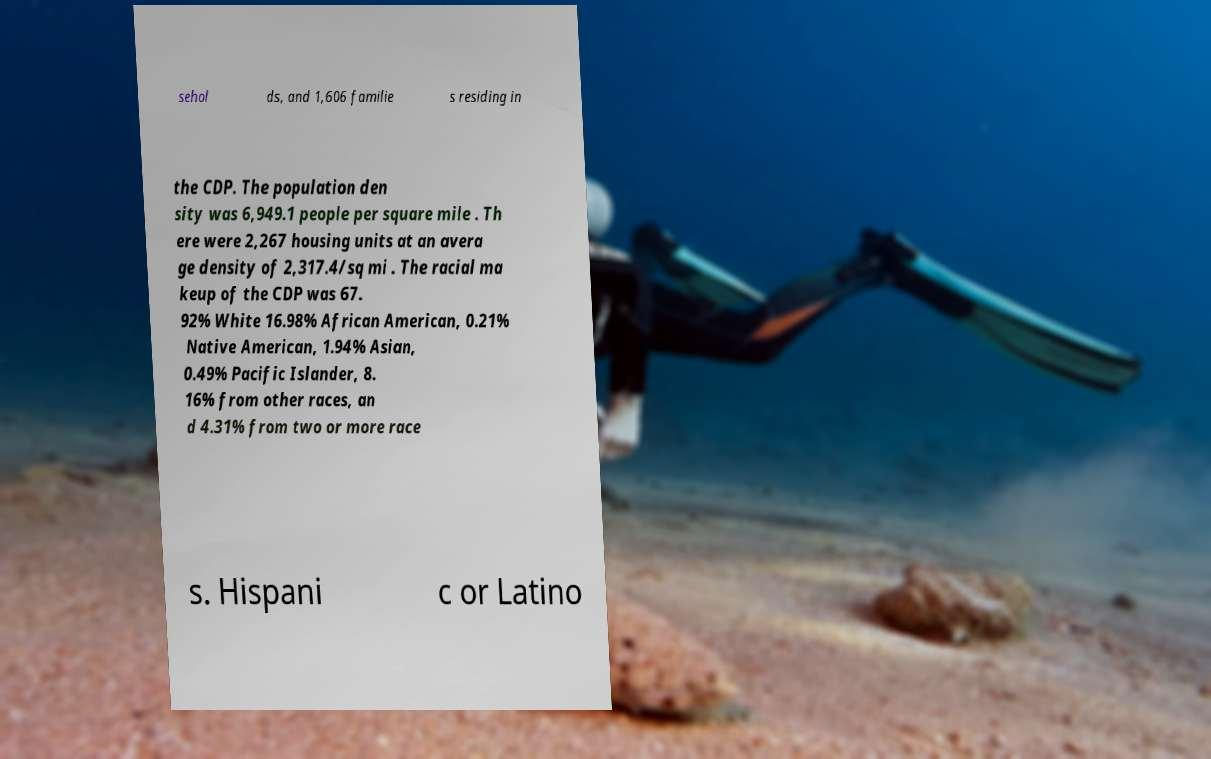There's text embedded in this image that I need extracted. Can you transcribe it verbatim? sehol ds, and 1,606 familie s residing in the CDP. The population den sity was 6,949.1 people per square mile . Th ere were 2,267 housing units at an avera ge density of 2,317.4/sq mi . The racial ma keup of the CDP was 67. 92% White 16.98% African American, 0.21% Native American, 1.94% Asian, 0.49% Pacific Islander, 8. 16% from other races, an d 4.31% from two or more race s. Hispani c or Latino 